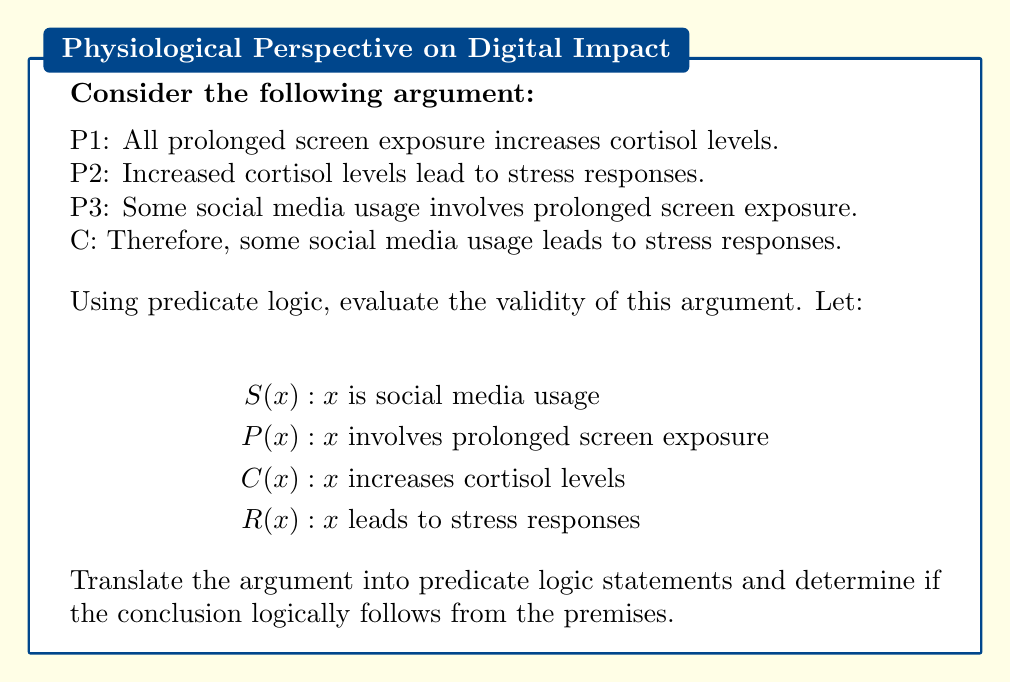Can you solve this math problem? Let's translate each premise and the conclusion into predicate logic:

P1: $\forall x (P(x) \rightarrow C(x))$
P2: $\forall x (C(x) \rightarrow R(x))$
P3: $\exists x (S(x) \land P(x))$
C: $\exists x (S(x) \land R(x))$

To prove the validity, we'll use a step-by-step logical deduction:

1) From P3: $\exists x (S(x) \land P(x))$
   Let's call this particular instance 'a', so we have: $S(a) \land P(a)$

2) From the conjunction in step 1, we can deduce: $P(a)$

3) From P1: $\forall x (P(x) \rightarrow C(x))$
   We can instantiate this with 'a': $P(a) \rightarrow C(a)$

4) Using Modus Ponens with steps 2 and 3, we get: $C(a)$

5) From P2: $\forall x (C(x) \rightarrow R(x))$
   We can instantiate this with 'a': $C(a) \rightarrow R(a)$

6) Using Modus Ponens with steps 4 and 5, we get: $R(a)$

7) From steps 1 and 6, we can form a conjunction: $S(a) \land R(a)$

8) From step 7, we can conclude: $\exists x (S(x) \land R(x))$

This matches our conclusion C, proving that the argument is valid in predicate logic.
Answer: Valid 